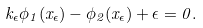<formula> <loc_0><loc_0><loc_500><loc_500>k _ { \epsilon } \phi _ { 1 } ( x _ { \epsilon } ) - \phi _ { 2 } ( x _ { \epsilon } ) + \epsilon = 0 .</formula> 